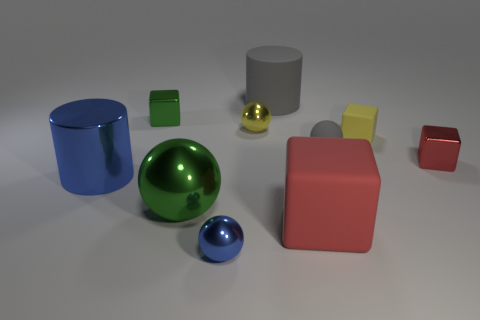Subtract all cubes. How many objects are left? 6 Subtract all large metallic things. Subtract all small green metallic objects. How many objects are left? 7 Add 6 big cylinders. How many big cylinders are left? 8 Add 9 large red matte objects. How many large red matte objects exist? 10 Subtract 0 blue blocks. How many objects are left? 10 